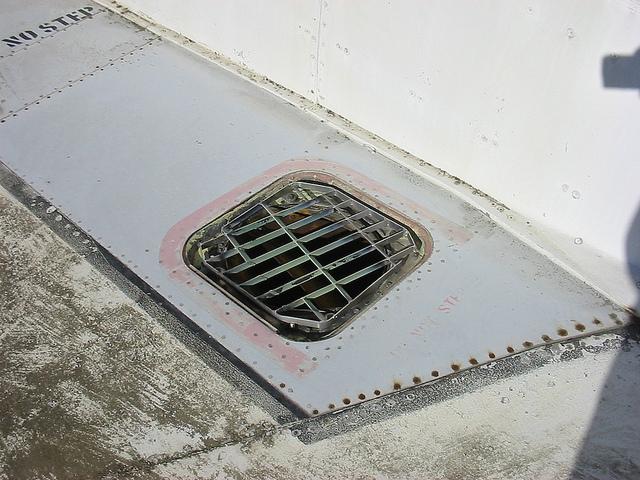Would you find the object that's in this photo somewhere on a ship?
Quick response, please. Yes. What does the picture say in the upper left corner?
Write a very short answer. No step. What is the hole for?
Write a very short answer. Water. 